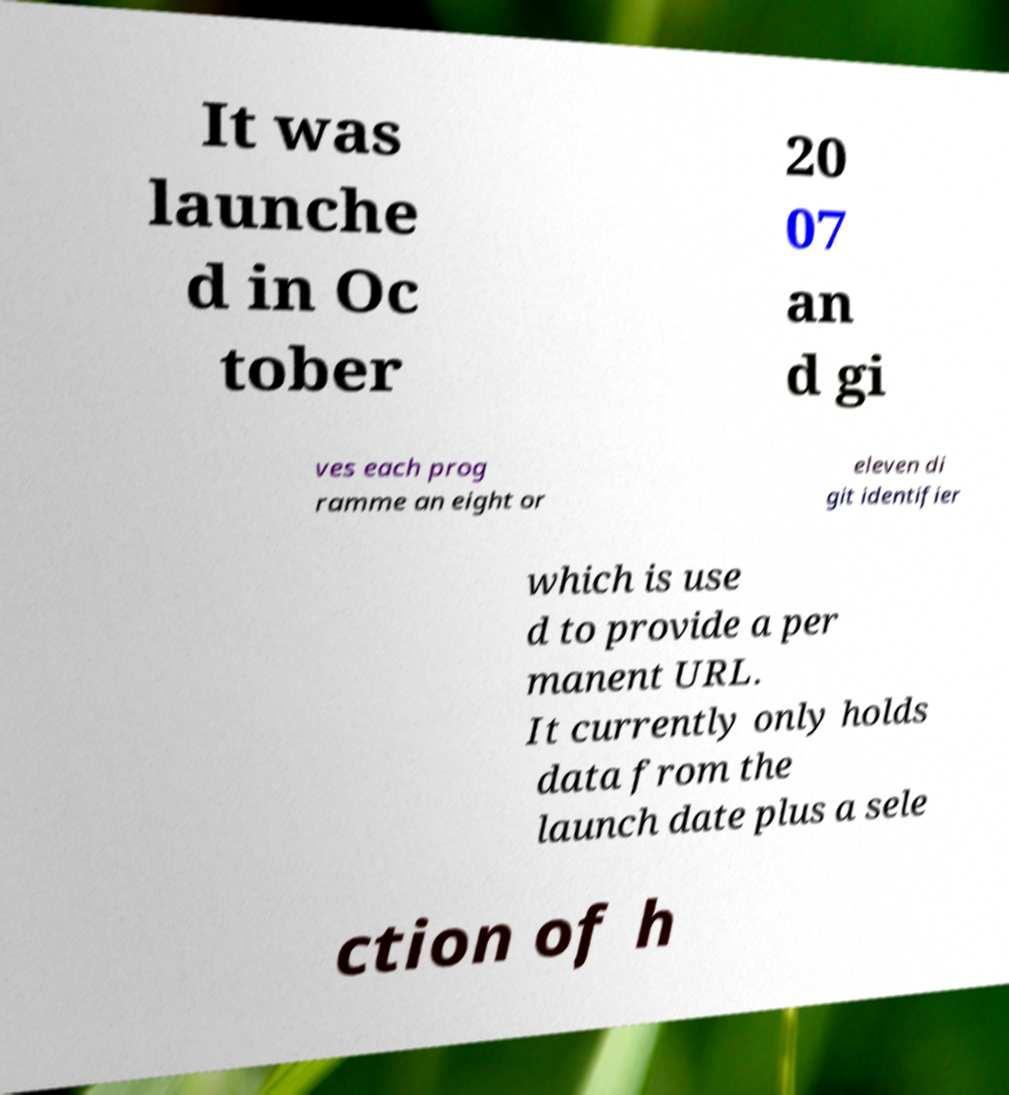I need the written content from this picture converted into text. Can you do that? It was launche d in Oc tober 20 07 an d gi ves each prog ramme an eight or eleven di git identifier which is use d to provide a per manent URL. It currently only holds data from the launch date plus a sele ction of h 